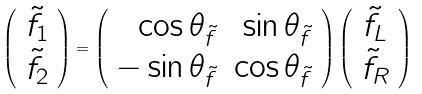Convert formula to latex. <formula><loc_0><loc_0><loc_500><loc_500>\left ( \begin{array} { c } { { \tilde { f } _ { 1 } } } \\ { { \tilde { f } _ { 2 } } } \end{array} \right ) = \left ( \begin{array} { r r } { { \cos \theta _ { \tilde { f } } } } & { { \sin \theta _ { \tilde { f } } } } \\ { { - \sin \theta _ { \tilde { f } } } } & { { \cos \theta _ { \tilde { f } } } } \end{array} \right ) \left ( \begin{array} { c } { { \tilde { f } _ { L } } } \\ { { \tilde { f } _ { R } } } \end{array} \right )</formula> 